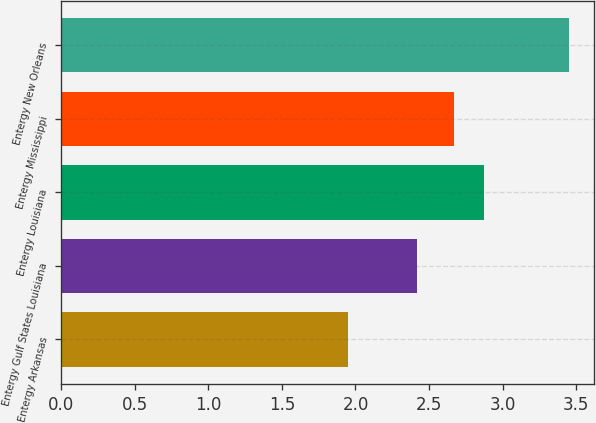Convert chart. <chart><loc_0><loc_0><loc_500><loc_500><bar_chart><fcel>Entergy Arkansas<fcel>Entergy Gulf States Louisiana<fcel>Entergy Louisiana<fcel>Entergy Mississippi<fcel>Entergy New Orleans<nl><fcel>1.95<fcel>2.42<fcel>2.87<fcel>2.67<fcel>3.45<nl></chart> 